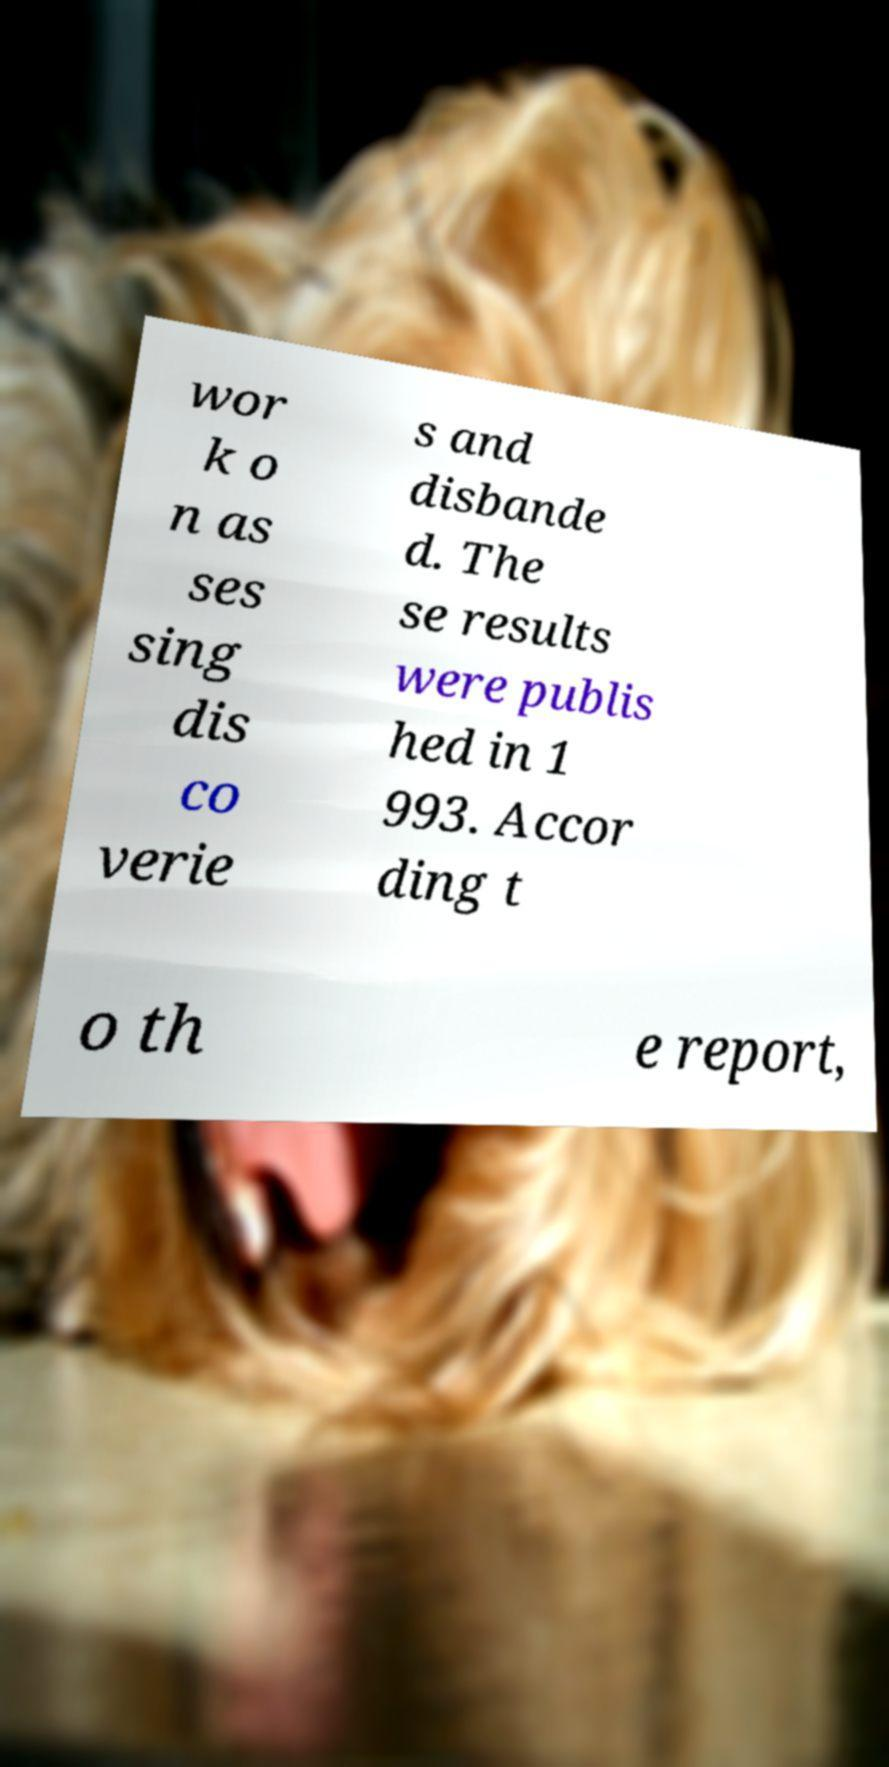For documentation purposes, I need the text within this image transcribed. Could you provide that? wor k o n as ses sing dis co verie s and disbande d. The se results were publis hed in 1 993. Accor ding t o th e report, 